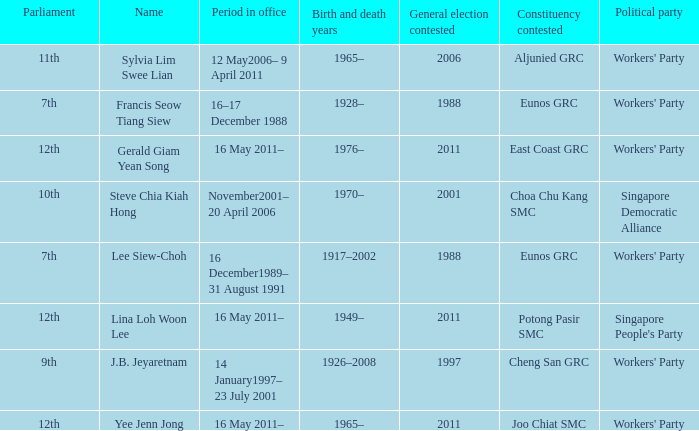What parliament's name is lina loh woon lee? 12th. 